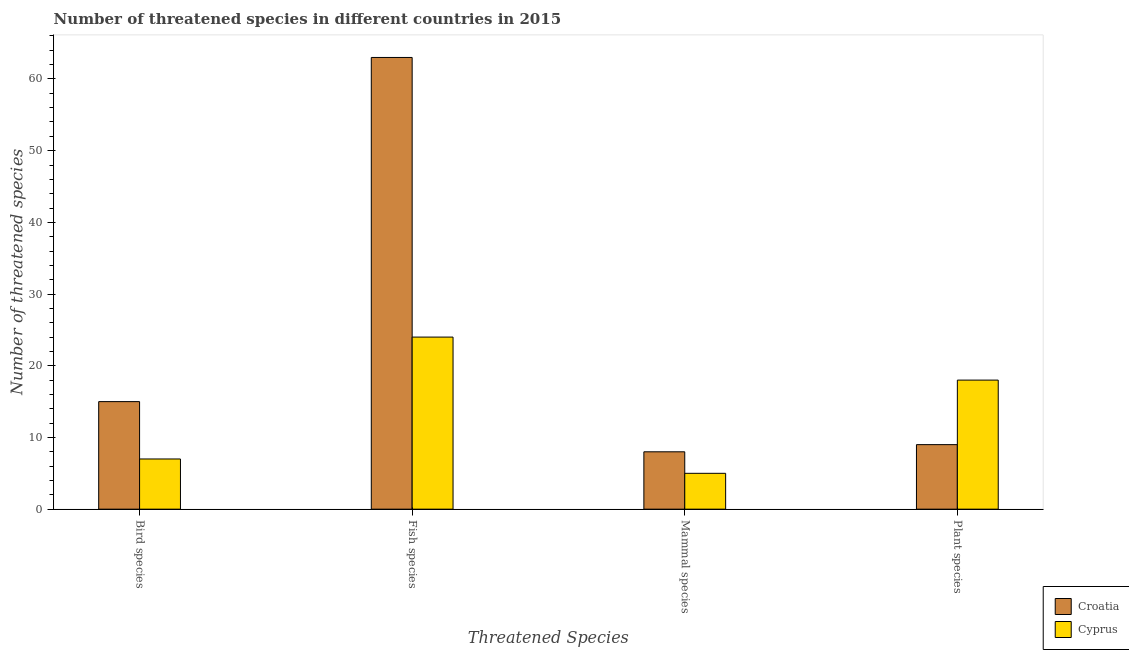How many groups of bars are there?
Provide a short and direct response. 4. Are the number of bars on each tick of the X-axis equal?
Keep it short and to the point. Yes. What is the label of the 4th group of bars from the left?
Ensure brevity in your answer.  Plant species. What is the number of threatened plant species in Cyprus?
Keep it short and to the point. 18. Across all countries, what is the maximum number of threatened fish species?
Give a very brief answer. 63. Across all countries, what is the minimum number of threatened mammal species?
Offer a very short reply. 5. In which country was the number of threatened plant species maximum?
Keep it short and to the point. Cyprus. In which country was the number of threatened plant species minimum?
Your response must be concise. Croatia. What is the total number of threatened bird species in the graph?
Offer a terse response. 22. What is the difference between the number of threatened fish species in Cyprus and that in Croatia?
Ensure brevity in your answer.  -39. What is the difference between the number of threatened mammal species in Cyprus and the number of threatened fish species in Croatia?
Provide a short and direct response. -58. What is the average number of threatened mammal species per country?
Offer a terse response. 6.5. What is the difference between the number of threatened fish species and number of threatened mammal species in Croatia?
Your answer should be very brief. 55. In how many countries, is the number of threatened mammal species greater than 4 ?
Keep it short and to the point. 2. What is the ratio of the number of threatened fish species in Croatia to that in Cyprus?
Ensure brevity in your answer.  2.62. Is the number of threatened fish species in Cyprus less than that in Croatia?
Your response must be concise. Yes. What is the difference between the highest and the lowest number of threatened fish species?
Make the answer very short. 39. Is the sum of the number of threatened bird species in Cyprus and Croatia greater than the maximum number of threatened fish species across all countries?
Ensure brevity in your answer.  No. What does the 2nd bar from the left in Bird species represents?
Keep it short and to the point. Cyprus. What does the 1st bar from the right in Mammal species represents?
Your response must be concise. Cyprus. Is it the case that in every country, the sum of the number of threatened bird species and number of threatened fish species is greater than the number of threatened mammal species?
Your answer should be very brief. Yes. How many bars are there?
Keep it short and to the point. 8. Does the graph contain any zero values?
Your response must be concise. No. Does the graph contain grids?
Offer a terse response. No. Where does the legend appear in the graph?
Your response must be concise. Bottom right. How many legend labels are there?
Provide a short and direct response. 2. What is the title of the graph?
Provide a short and direct response. Number of threatened species in different countries in 2015. What is the label or title of the X-axis?
Give a very brief answer. Threatened Species. What is the label or title of the Y-axis?
Provide a succinct answer. Number of threatened species. What is the Number of threatened species of Croatia in Bird species?
Keep it short and to the point. 15. What is the Number of threatened species in Croatia in Fish species?
Offer a terse response. 63. What is the Number of threatened species in Cyprus in Fish species?
Your answer should be compact. 24. What is the Number of threatened species in Croatia in Mammal species?
Make the answer very short. 8. What is the Number of threatened species of Cyprus in Mammal species?
Your answer should be compact. 5. What is the Number of threatened species in Cyprus in Plant species?
Make the answer very short. 18. Across all Threatened Species, what is the maximum Number of threatened species in Croatia?
Give a very brief answer. 63. Across all Threatened Species, what is the maximum Number of threatened species in Cyprus?
Offer a terse response. 24. Across all Threatened Species, what is the minimum Number of threatened species in Croatia?
Your response must be concise. 8. What is the total Number of threatened species in Cyprus in the graph?
Provide a short and direct response. 54. What is the difference between the Number of threatened species of Croatia in Bird species and that in Fish species?
Your response must be concise. -48. What is the difference between the Number of threatened species of Cyprus in Bird species and that in Mammal species?
Provide a succinct answer. 2. What is the difference between the Number of threatened species in Cyprus in Bird species and that in Plant species?
Ensure brevity in your answer.  -11. What is the difference between the Number of threatened species of Cyprus in Fish species and that in Mammal species?
Ensure brevity in your answer.  19. What is the difference between the Number of threatened species in Croatia in Fish species and that in Plant species?
Provide a succinct answer. 54. What is the difference between the Number of threatened species of Cyprus in Fish species and that in Plant species?
Keep it short and to the point. 6. What is the difference between the Number of threatened species in Croatia in Mammal species and that in Plant species?
Provide a succinct answer. -1. What is the difference between the Number of threatened species of Cyprus in Mammal species and that in Plant species?
Your answer should be compact. -13. What is the difference between the Number of threatened species in Croatia in Bird species and the Number of threatened species in Cyprus in Fish species?
Provide a short and direct response. -9. What is the difference between the Number of threatened species in Croatia in Bird species and the Number of threatened species in Cyprus in Mammal species?
Offer a very short reply. 10. What is the difference between the Number of threatened species of Croatia in Fish species and the Number of threatened species of Cyprus in Mammal species?
Your answer should be very brief. 58. What is the difference between the Number of threatened species of Croatia in Fish species and the Number of threatened species of Cyprus in Plant species?
Keep it short and to the point. 45. What is the average Number of threatened species of Croatia per Threatened Species?
Offer a very short reply. 23.75. What is the average Number of threatened species of Cyprus per Threatened Species?
Provide a succinct answer. 13.5. What is the difference between the Number of threatened species in Croatia and Number of threatened species in Cyprus in Fish species?
Ensure brevity in your answer.  39. What is the difference between the Number of threatened species in Croatia and Number of threatened species in Cyprus in Mammal species?
Offer a terse response. 3. What is the difference between the Number of threatened species of Croatia and Number of threatened species of Cyprus in Plant species?
Your answer should be very brief. -9. What is the ratio of the Number of threatened species of Croatia in Bird species to that in Fish species?
Your answer should be very brief. 0.24. What is the ratio of the Number of threatened species in Cyprus in Bird species to that in Fish species?
Ensure brevity in your answer.  0.29. What is the ratio of the Number of threatened species in Croatia in Bird species to that in Mammal species?
Your answer should be compact. 1.88. What is the ratio of the Number of threatened species in Croatia in Bird species to that in Plant species?
Give a very brief answer. 1.67. What is the ratio of the Number of threatened species of Cyprus in Bird species to that in Plant species?
Keep it short and to the point. 0.39. What is the ratio of the Number of threatened species of Croatia in Fish species to that in Mammal species?
Keep it short and to the point. 7.88. What is the ratio of the Number of threatened species of Croatia in Fish species to that in Plant species?
Keep it short and to the point. 7. What is the ratio of the Number of threatened species in Croatia in Mammal species to that in Plant species?
Make the answer very short. 0.89. What is the ratio of the Number of threatened species of Cyprus in Mammal species to that in Plant species?
Your answer should be very brief. 0.28. What is the difference between the highest and the lowest Number of threatened species in Cyprus?
Your answer should be compact. 19. 